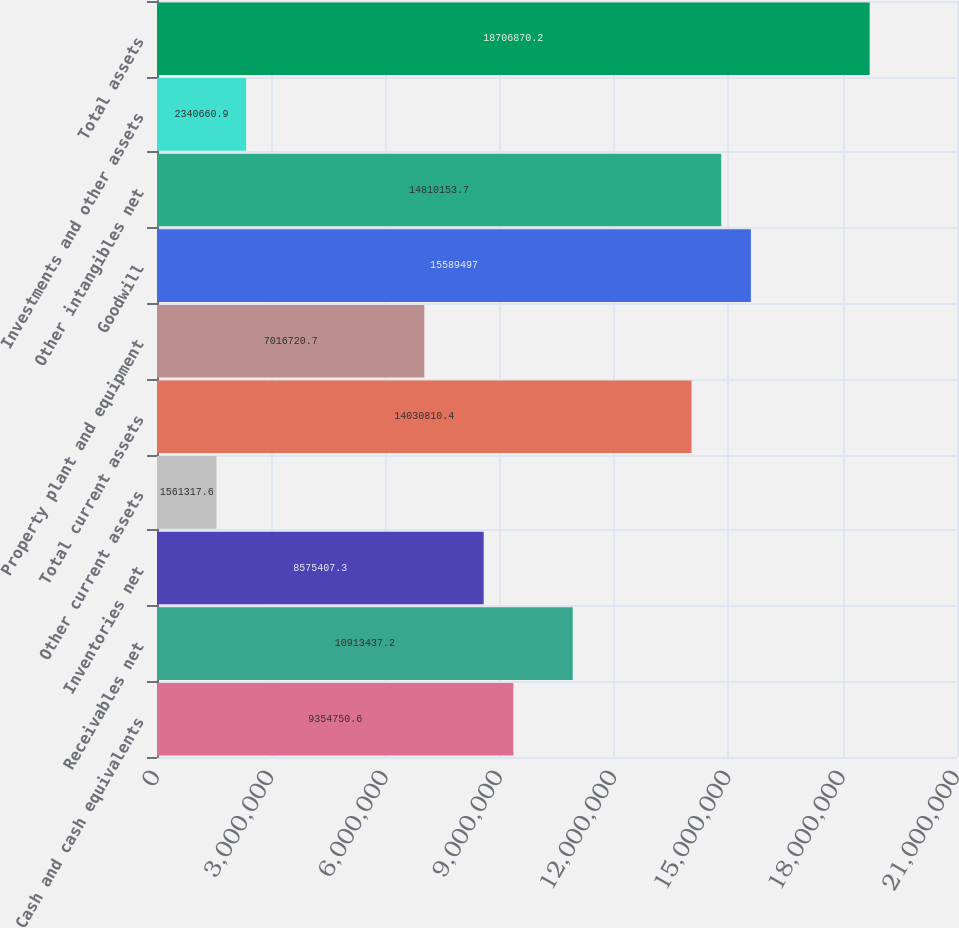<chart> <loc_0><loc_0><loc_500><loc_500><bar_chart><fcel>Cash and cash equivalents<fcel>Receivables net<fcel>Inventories net<fcel>Other current assets<fcel>Total current assets<fcel>Property plant and equipment<fcel>Goodwill<fcel>Other intangibles net<fcel>Investments and other assets<fcel>Total assets<nl><fcel>9.35475e+06<fcel>1.09134e+07<fcel>8.57541e+06<fcel>1.56132e+06<fcel>1.40308e+07<fcel>7.01672e+06<fcel>1.55895e+07<fcel>1.48102e+07<fcel>2.34066e+06<fcel>1.87069e+07<nl></chart> 